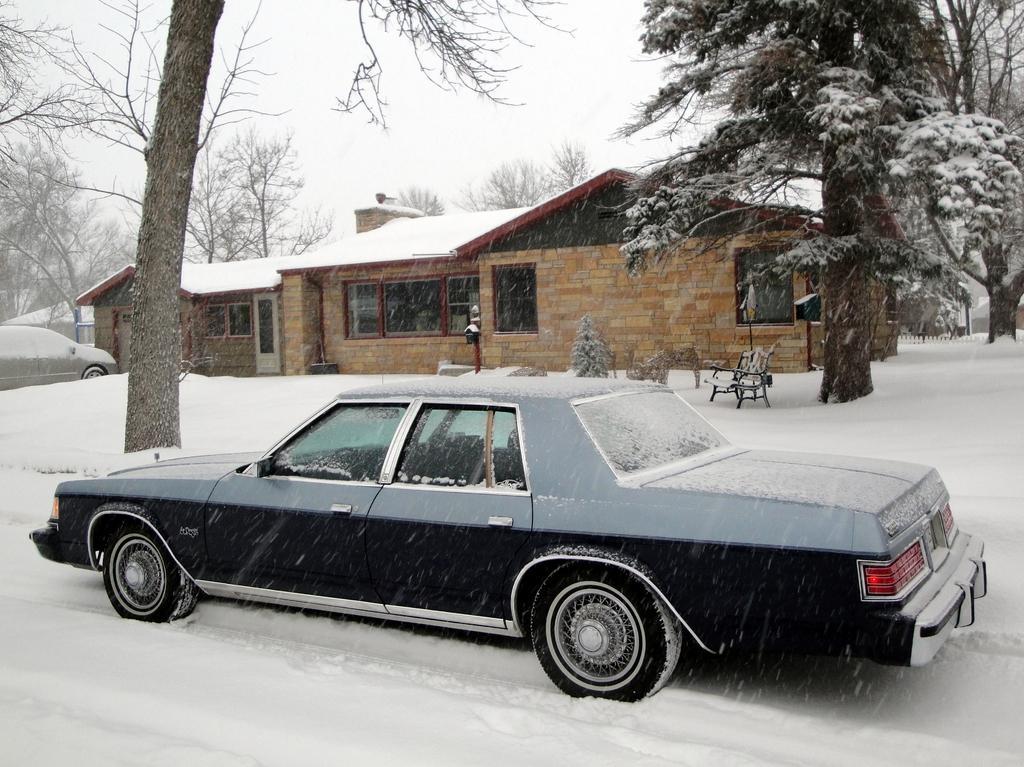In one or two sentences, can you explain what this image depicts? In the picture we can see a snowy surface on it, we can see a car which is black in color and beside it, we can see a tree and near to it, we can see another tree and a chair and behind it, we can see a house with glass windows and on the top of the house we can see snow and in the background we can see trees and sky. 